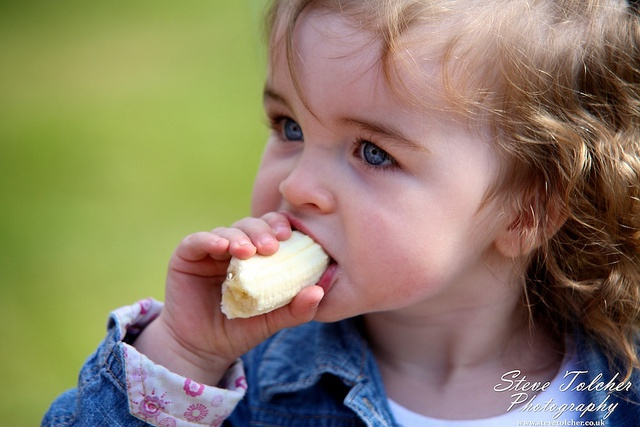Describe the objects in this image and their specific colors. I can see people in darkgreen, gray, darkgray, lightpink, and black tones and banana in darkgreen, ivory, and tan tones in this image. 